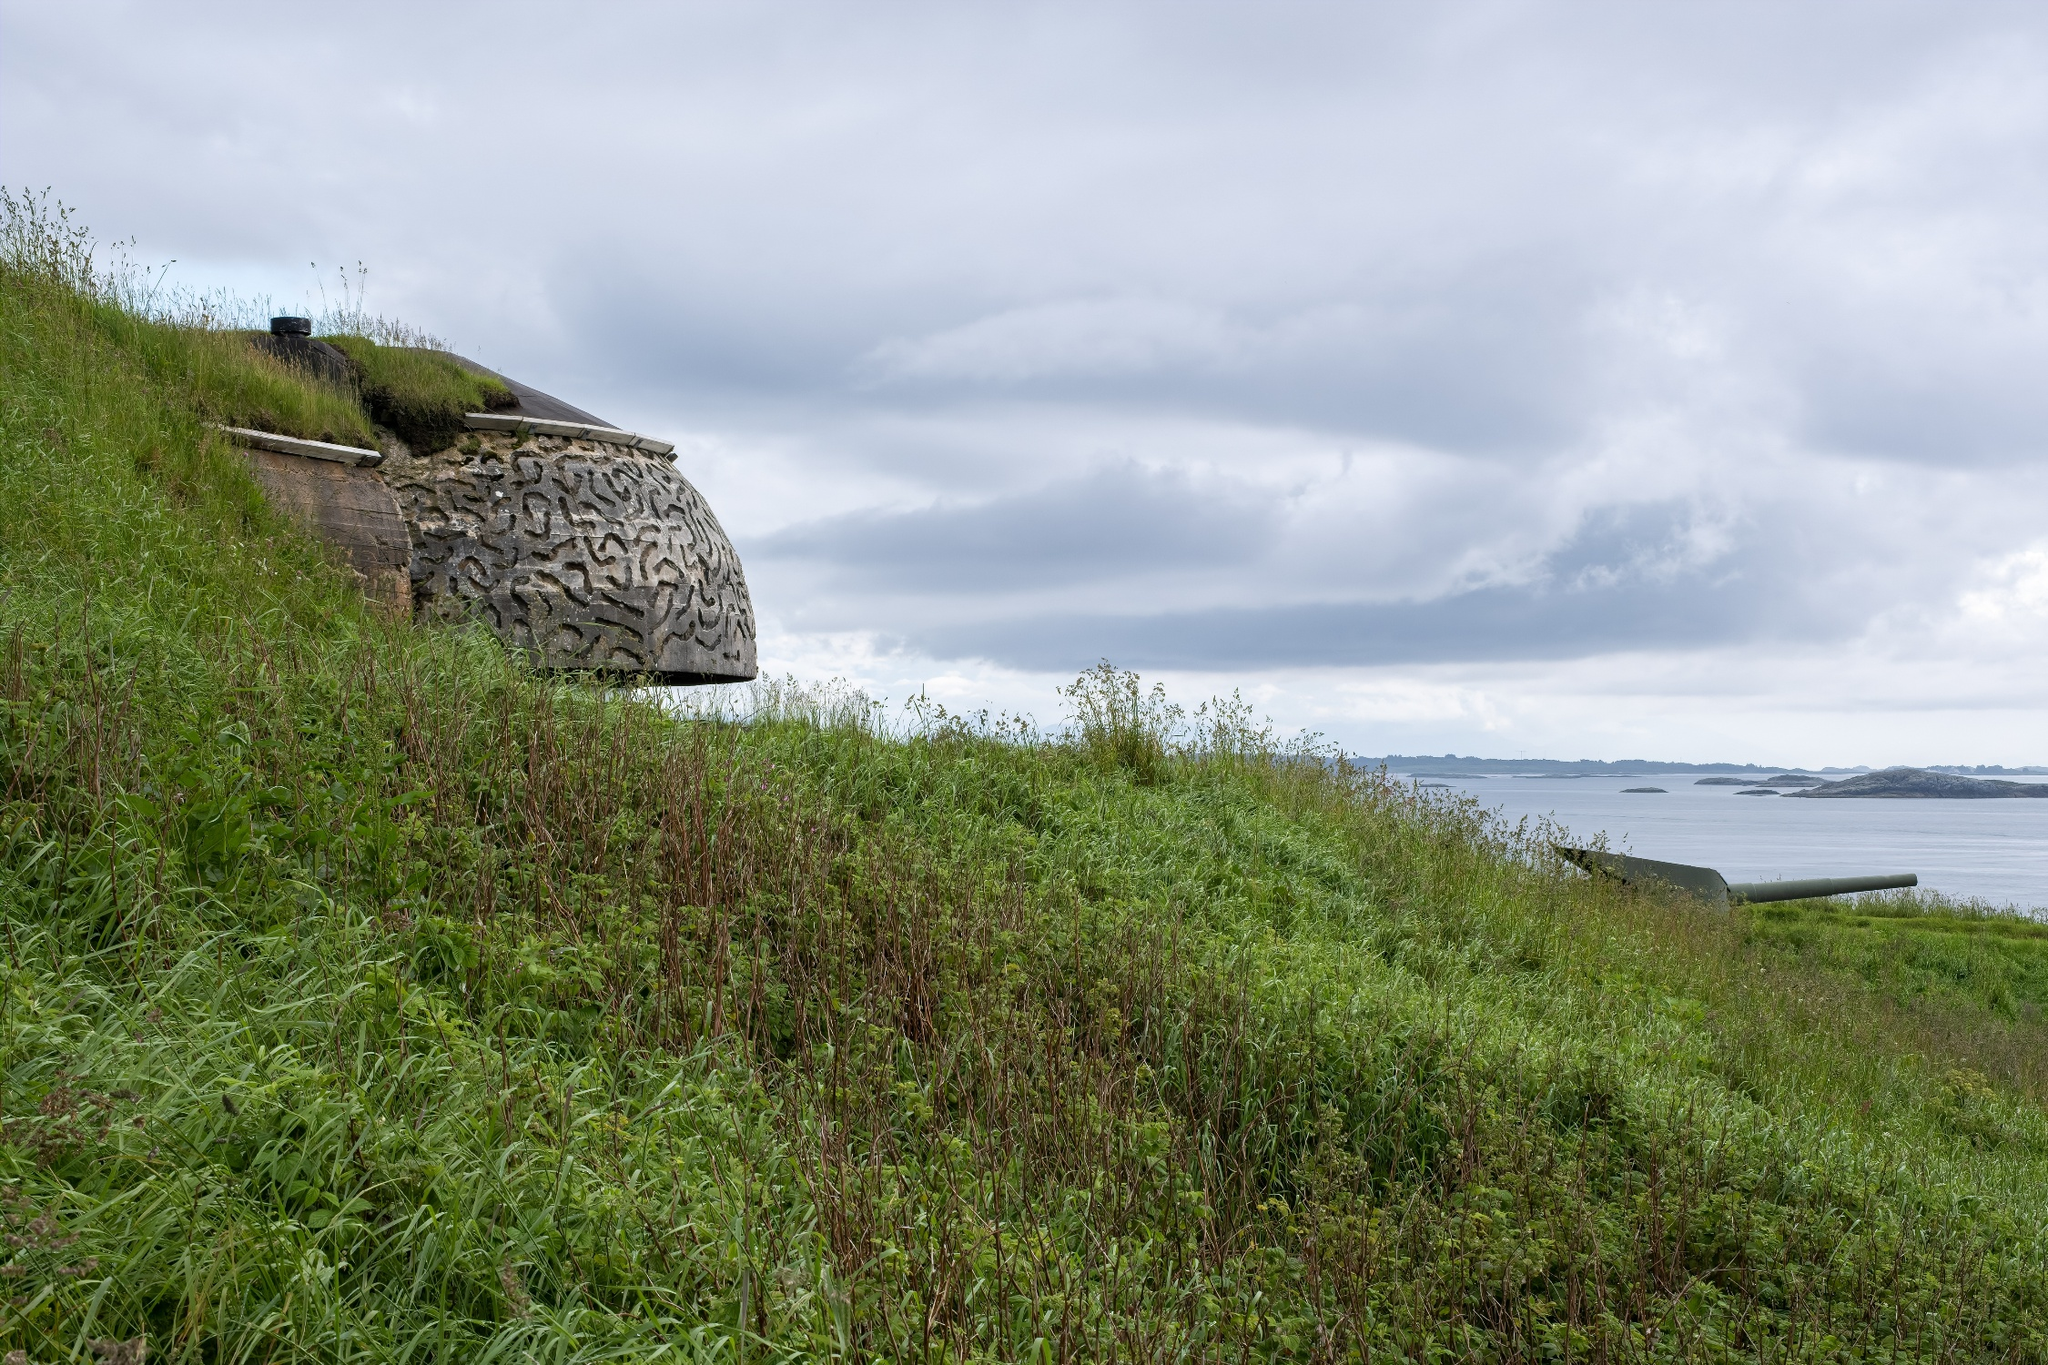Imagine the bunker is a portal to different time periods. How does the surroundings change through each period? Engaging the portal within the stone bunker, each epoch unveils a distinctive transformation of the surroundings:
1. **World War II Era:** This period sees the bunker in its prime. The surrounding hillside is clear of significant vegetation, offering an unobstructed view of the ocean which is now bustling with naval activity. The area is animated with soldiers, their voices filled with urgency and purpose.
2. **Post-War Reconstruction:** Moving forward, the hillside begins to sprout grass and shrubs. The bunker remains, though slightly weathered, standing as a silent sentinel as locals work to rebuild their lives. The ocean waters start to return to a peaceful, everyday rhythm.
3. **Late 20th Century:** The surroundings flourish with greenery, indicating years of relative peace. The bunker is now a relic of history, visited occasionally by hikers and history enthusiasts. The ocean remains tranquil, reflecting the mellowing pace of life.
4. **Present Day:** The landscape is at its most serene and harmonious. The lush green hillside is teeming with small wildlife, and the sky's cloud tapestry changes with the winds. The ocean is a vast, calm expanse, and the bunker, though weathered, inspires awe in those who visit and ponder its past.
5. **Future - Rewilding Era:** Nature fully embraces the area, with the hillside transformed into a diverse ecosystem. The bunker is almost completely enveloped by creeping vines and plant life, becoming an integral, albeit mysterious, part of the landscape. The ocean, now part of a protected marine reserve, thrives with aquatic life. The overall ambiance is one of profound tranquility and natural harmony. 